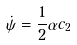<formula> <loc_0><loc_0><loc_500><loc_500>\dot { \psi } = \frac { 1 } { 2 } \alpha c _ { 2 }</formula> 